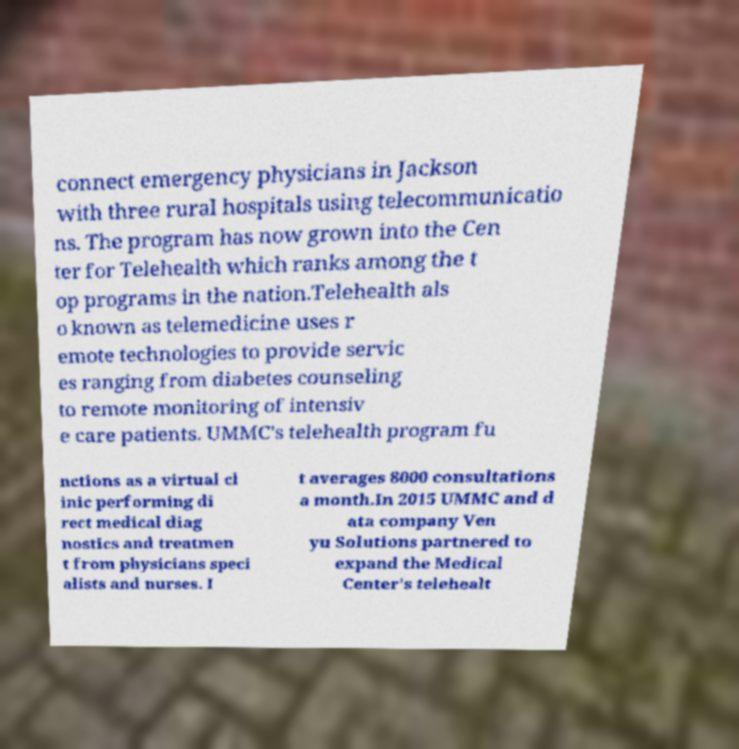Please read and relay the text visible in this image. What does it say? connect emergency physicians in Jackson with three rural hospitals using telecommunicatio ns. The program has now grown into the Cen ter for Telehealth which ranks among the t op programs in the nation.Telehealth als o known as telemedicine uses r emote technologies to provide servic es ranging from diabetes counseling to remote monitoring of intensiv e care patients. UMMC's telehealth program fu nctions as a virtual cl inic performing di rect medical diag nostics and treatmen t from physicians speci alists and nurses. I t averages 8000 consultations a month.In 2015 UMMC and d ata company Ven yu Solutions partnered to expand the Medical Center's telehealt 